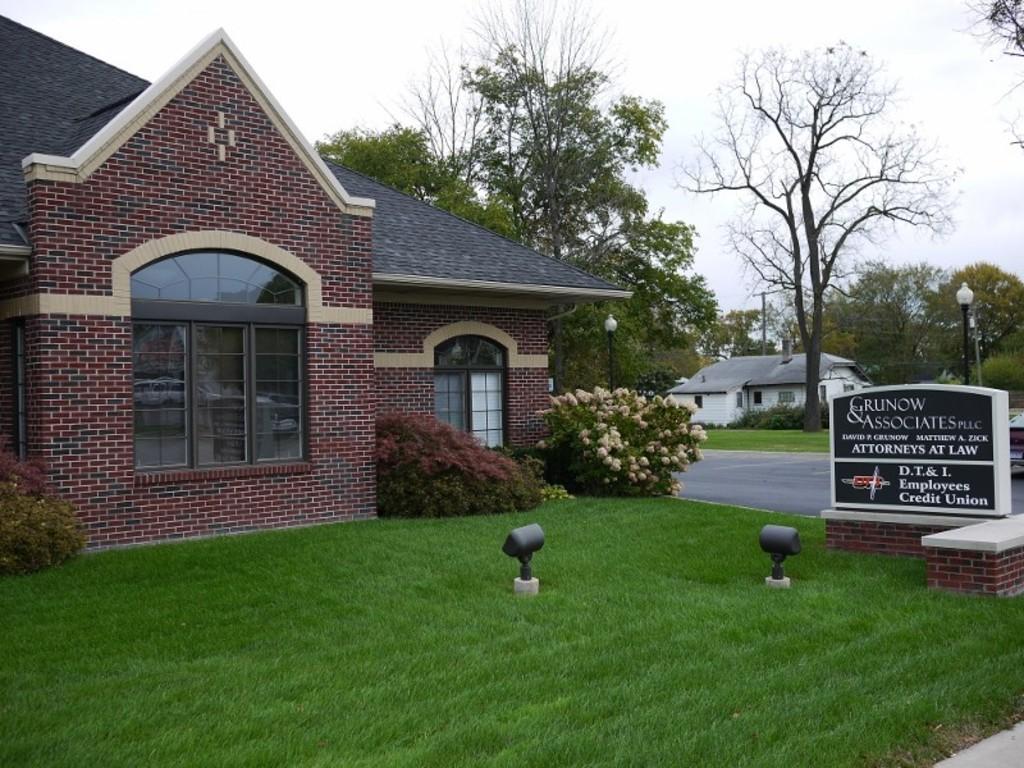Please provide a concise description of this image. In this image we can see grass on the ground, objects, texts written on a board on a platform. In the background we can see houses, windows, trees, plants with flowers, road, light poles and clouds in the sky. 